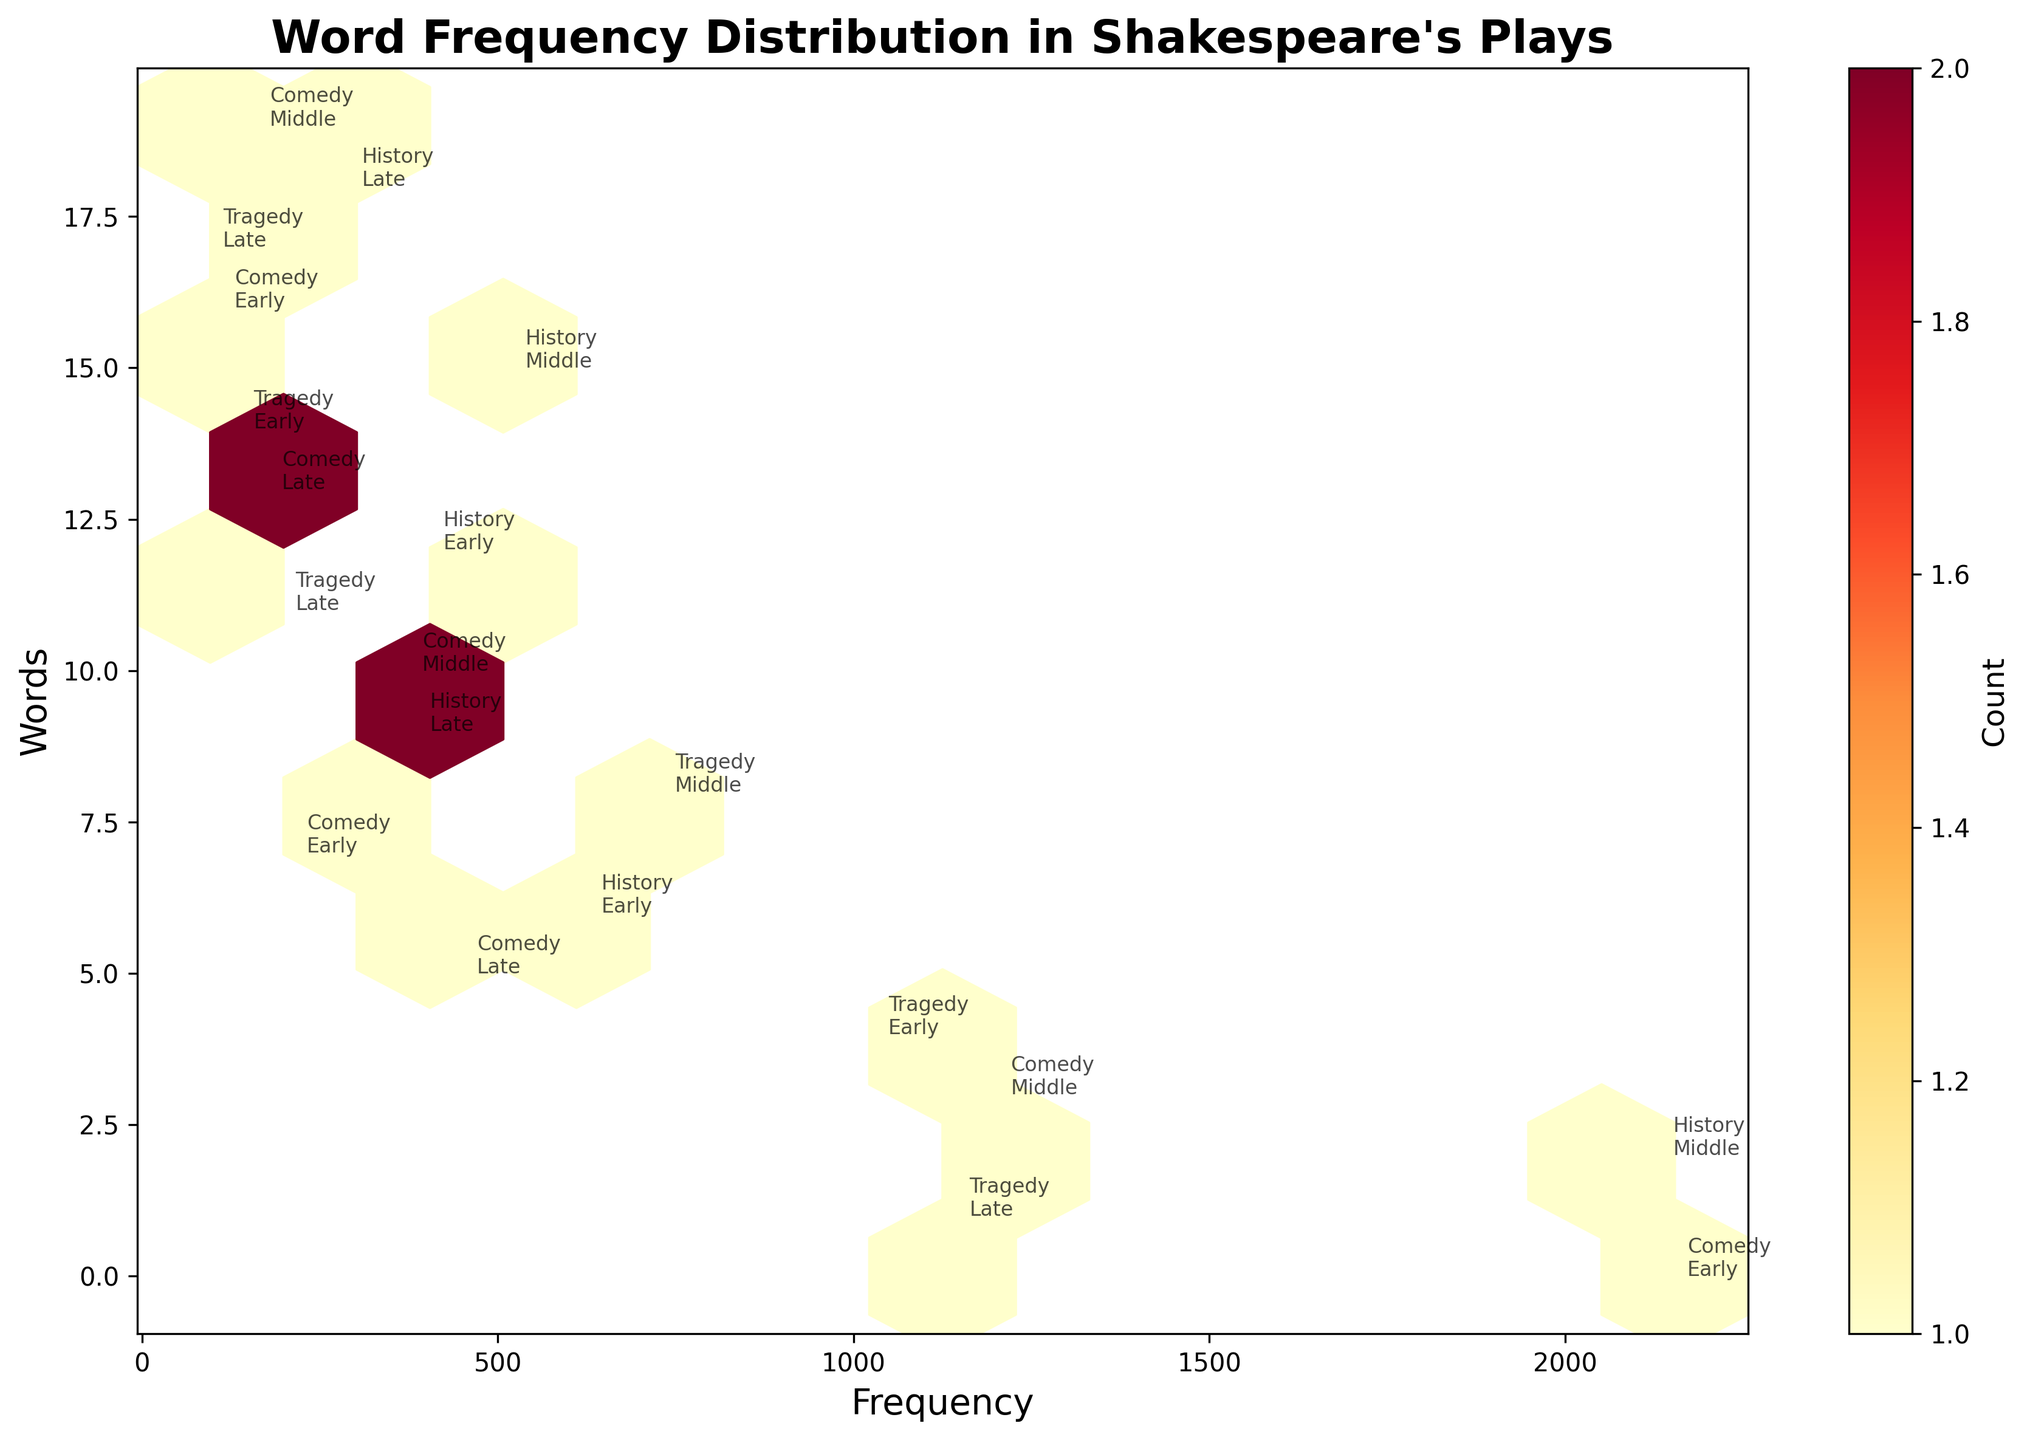What is the title of the plot? The title is displayed at the top of the figure. It reads "Word Frequency Distribution in Shakespeare's Plays."
Answer: Word Frequency Distribution in Shakespeare's Plays How many genres are represented in the figure? By looking at the annotations next to the hexagons in the plot, we can see the genres labeled as "Comedy," "Tragedy," and "History," which totals three genres.
Answer: 3 Which word has the highest frequency? The highest frequency is represented by the hexagon farthest to the right on the x-axis. The annotation next to this hexagon shows “Comedy Early” for the word "love" with a frequency of 2154.
Answer: love Which genre has the highest word frequency among the listed words? By checking the annotations with the highest frequency values, we see "love" in the "Comedy Early" genre with a frequency of 2154, which is higher than any other word in any genre.
Answer: Comedy Compare the frequency of the word "time" to "blood." Which one appears more frequently? First, identify the frequency of "time" which is 1203 and 'blood' which is 731 from their annotations. Comparing these two values, "time" has a higher frequency.
Answer: time How many words fall into the "Late" period category? By observing the annotations, words such as "death," "fool," "crown," "fate," "ghost," and "battle" belong to the "Late" period category. Counting these, we get a total of six words.
Answer: 6 Which word in the Comedy genre has the lowest frequency? Observing the frequencies and annotations for the Comedy genre, the word "jest" has the lowest frequency of 112.
Answer: jest Are there any words in the "Early" period that have a frequency greater than 500? By looking at the annotations for the "Early" period, we see "love" with a frequency of 2154, "war" with 628, and "sword" with 406. Hence, "love" and "war" both have frequencies greater than 500.
Answer: Yes What is the difference in frequency between the word "king" and "war"? The frequency of "king" is 2134 and for "war" it is 628. The difference is calculated as 2134 - 628 which equals 1506.
Answer: 1506 